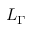<formula> <loc_0><loc_0><loc_500><loc_500>L _ { \Gamma }</formula> 